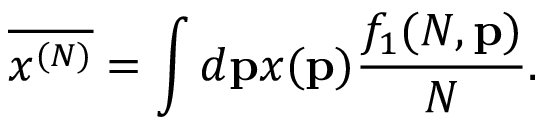Convert formula to latex. <formula><loc_0><loc_0><loc_500><loc_500>\overline { { { x ^ { ( N ) } } } } = \int d { p } x ( { p } ) \frac { f _ { 1 } ( N , { p } ) } { N } .</formula> 